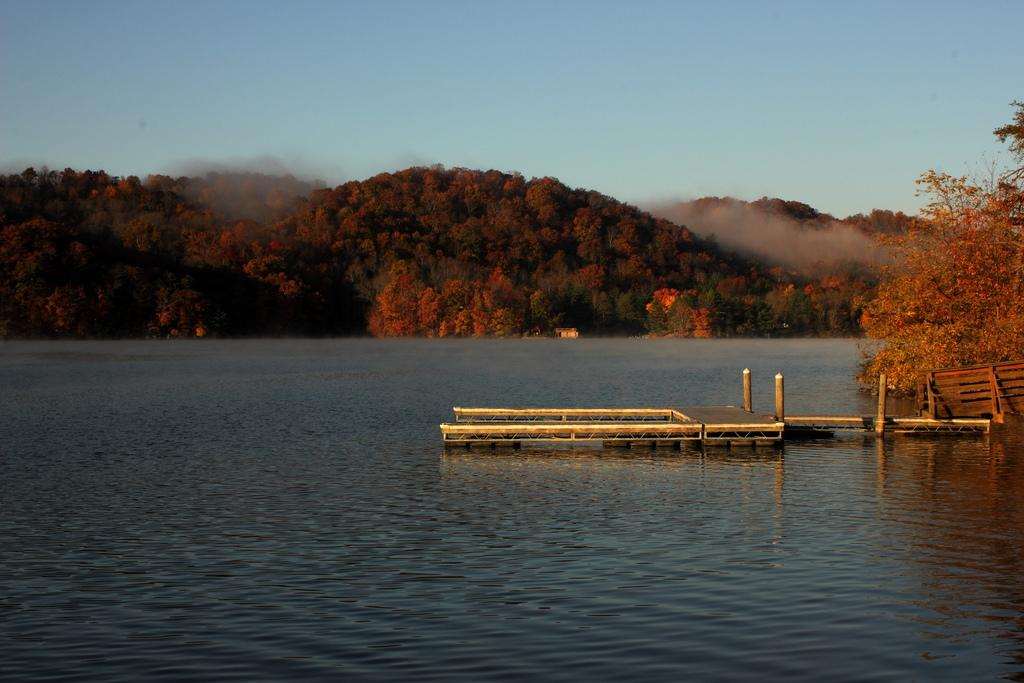What is located in the water in the image? There is a deck with poles in the water. What type of vegetation can be seen in the image? There are plants visible in the image. What can be seen in the background of the image? There is a group of trees on the hills in the background. How would you describe the sky in the image? The sky is visible and appears cloudy. How many cakes are being served on the deck in the image? There is no mention of cakes in the image; it features a deck with poles in the water, plants, a group of trees in the background, and a cloudy sky. 